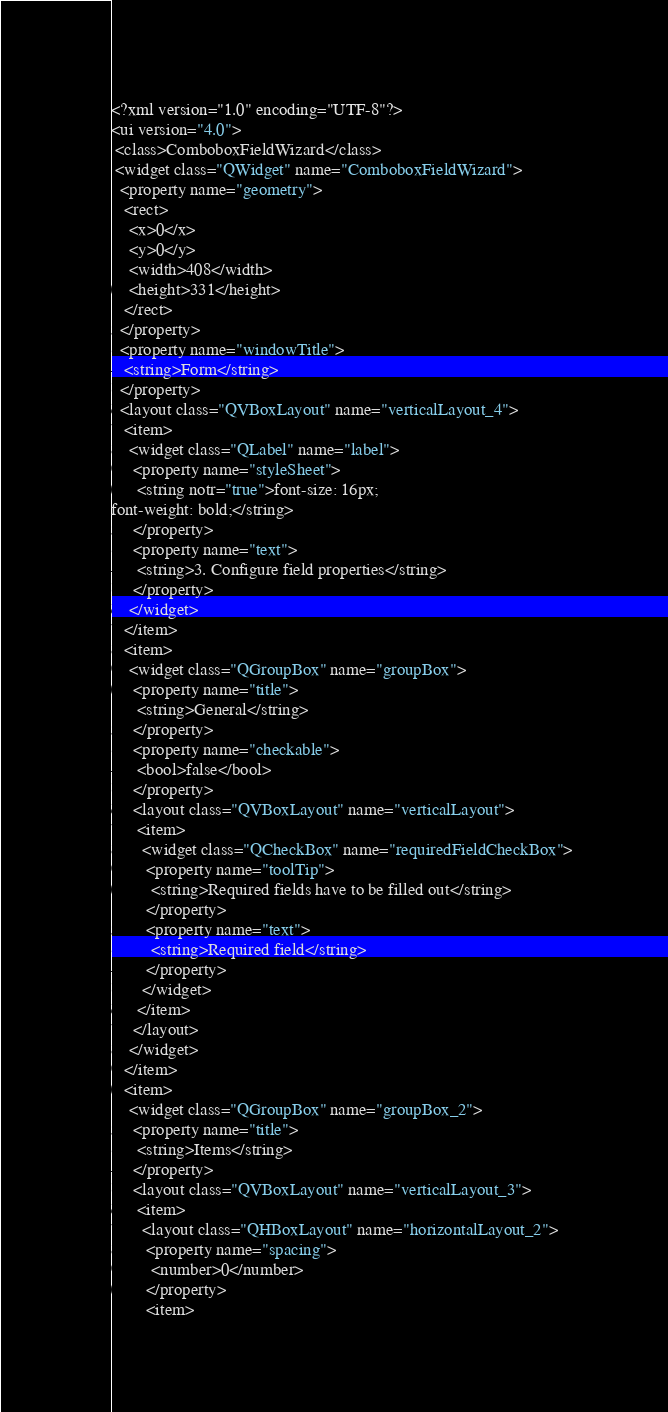<code> <loc_0><loc_0><loc_500><loc_500><_XML_><?xml version="1.0" encoding="UTF-8"?>
<ui version="4.0">
 <class>ComboboxFieldWizard</class>
 <widget class="QWidget" name="ComboboxFieldWizard">
  <property name="geometry">
   <rect>
    <x>0</x>
    <y>0</y>
    <width>408</width>
    <height>331</height>
   </rect>
  </property>
  <property name="windowTitle">
   <string>Form</string>
  </property>
  <layout class="QVBoxLayout" name="verticalLayout_4">
   <item>
    <widget class="QLabel" name="label">
     <property name="styleSheet">
      <string notr="true">font-size: 16px;
font-weight: bold;</string>
     </property>
     <property name="text">
      <string>3. Configure field properties</string>
     </property>
    </widget>
   </item>
   <item>
    <widget class="QGroupBox" name="groupBox">
     <property name="title">
      <string>General</string>
     </property>
     <property name="checkable">
      <bool>false</bool>
     </property>
     <layout class="QVBoxLayout" name="verticalLayout">
      <item>
       <widget class="QCheckBox" name="requiredFieldCheckBox">
        <property name="toolTip">
         <string>Required fields have to be filled out</string>
        </property>
        <property name="text">
         <string>Required field</string>
        </property>
       </widget>
      </item>
     </layout>
    </widget>
   </item>
   <item>
    <widget class="QGroupBox" name="groupBox_2">
     <property name="title">
      <string>Items</string>
     </property>
     <layout class="QVBoxLayout" name="verticalLayout_3">
      <item>
       <layout class="QHBoxLayout" name="horizontalLayout_2">
        <property name="spacing">
         <number>0</number>
        </property>
        <item></code> 